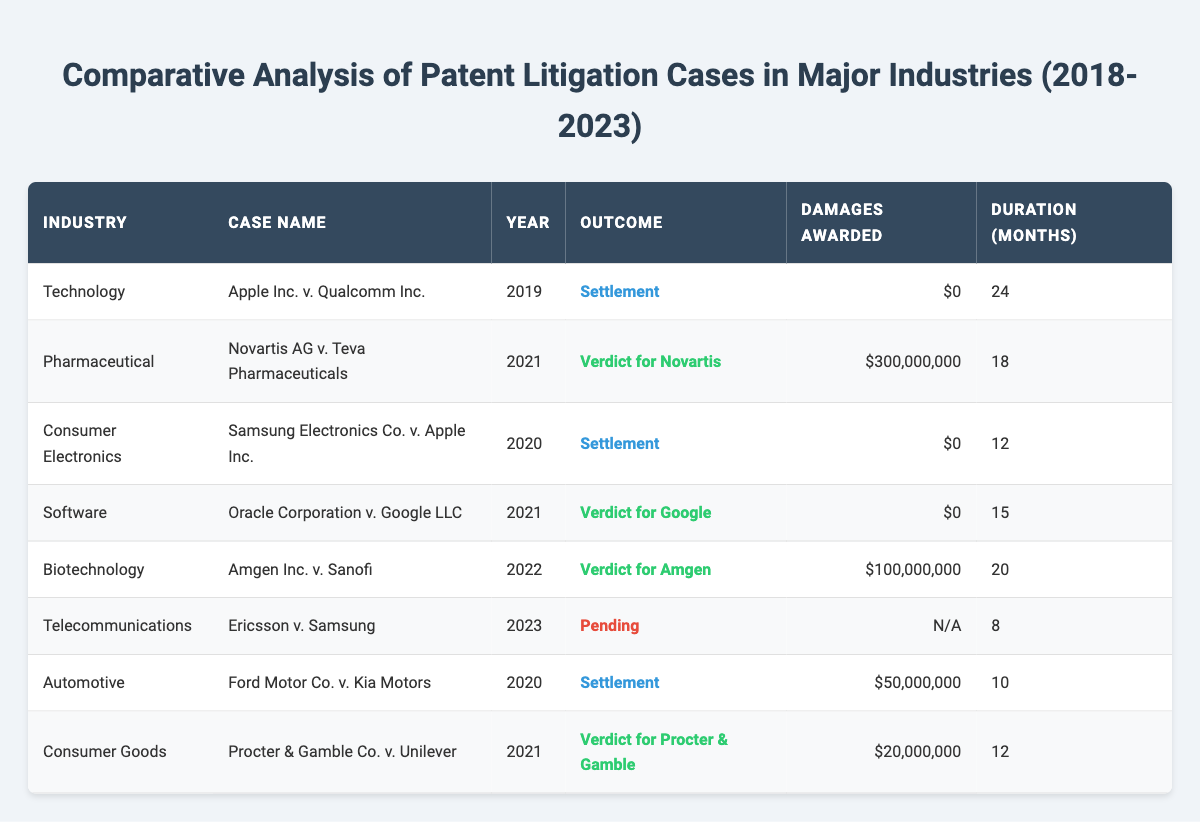What is the outcome of the case "Novartis AG v. Teva Pharmaceuticals"? In the table, under the column for the case name "Novartis AG v. Teva Pharmaceuticals," the corresponding outcome is listed as "Verdict for Novartis."
Answer: Verdict for Novartis How many months did the "Apple Inc. v. Qualcomm Inc." case last? Looking at the row for "Apple Inc. v. Qualcomm Inc.," the duration column indicates that this case lasted for 24 months.
Answer: 24 What is the total amount of damages awarded in the Pharmaceutical industry cases? There is one case in the Pharmaceutical industry: "Novartis AG v. Teva Pharmaceuticals" with damages awarded of 300,000,000. Since it's the only case, the total amount is 300,000,000.
Answer: 300,000,000 Are there any cases in the table where the outcome is pending? The case "Ericsson v. Samsung" listed in the table has the outcome marked as "Pending." Thus, the answer is yes, there is at least one case with a pending outcome.
Answer: Yes Which industry had the longest duration for patent litigation cases based on the table? By reviewing the duration of each case, "Apple Inc. v. Qualcomm Inc." (Technology) has 24 months and is the longest noted. Therefore, the Technology industry had the longest duration.
Answer: Technology What is the average duration of cases that ended with a settlement? The cases that ended in a settlement are: "Apple Inc. v. Qualcomm Inc." (24 months), "Samsung Electronics Co. v. Apple Inc." (12 months), and "Ford Motor Co. v. Kia Motors" (10 months). Adding these gives 24 + 12 + 10 = 46 months. Divide by 3 (the number of cases) gives an average duration of 46 / 3 = 15.33 months.
Answer: 15.33 months How many cases resulted in a verdict for the plaintiff? From the table, the cases resulting in a verdict for the plaintiff (Novartis and Procter & Gamble) are two: "Novartis AG v. Teva Pharmaceuticals" and "Amgen Inc. v. Sanofi," and there are no verdicts listed for the other cases. Therefore, the count is two.
Answer: 2 Which industry had the highest damages awarded based on the cases listed? In reviewing the damages awarded, the highest value is found in the Pharmaceutical industry case "Novartis AG v. Teva Pharmaceuticals" with damages awarded of 300,000,000. Therefore, the highest is in the Pharmaceutical industry.
Answer: Pharmaceutical How many months did the "Ericsson v. Samsung" case last, and what is its outcome? The case "Ericsson v. Samsung" lasted for 8 months and has the outcome marked as "Pending." Thus, it lasted for 8 months with that outcome.
Answer: 8 months, Pending 